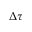Convert formula to latex. <formula><loc_0><loc_0><loc_500><loc_500>\Delta \tau</formula> 